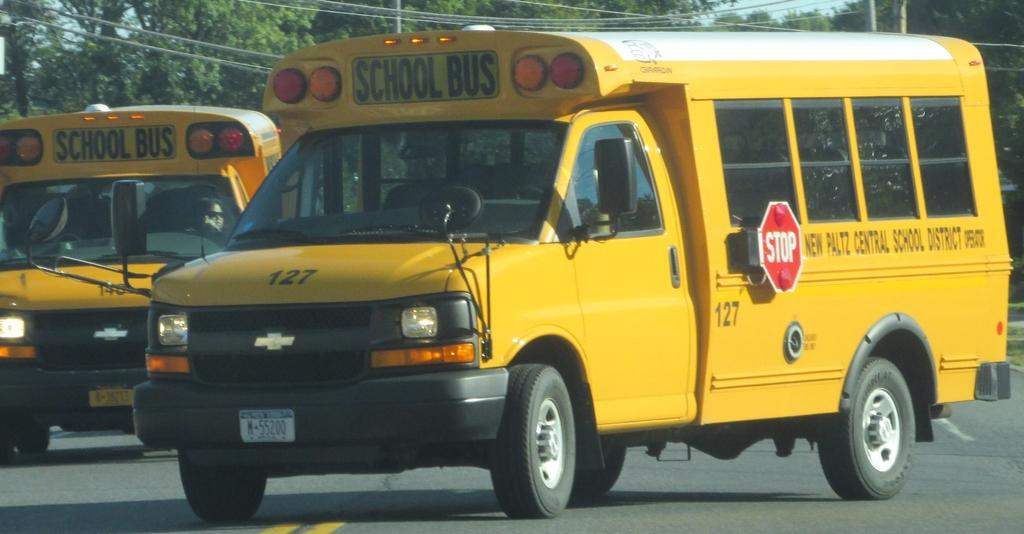<image>
Offer a succinct explanation of the picture presented. a bus that has a stop sign on the left side of it 